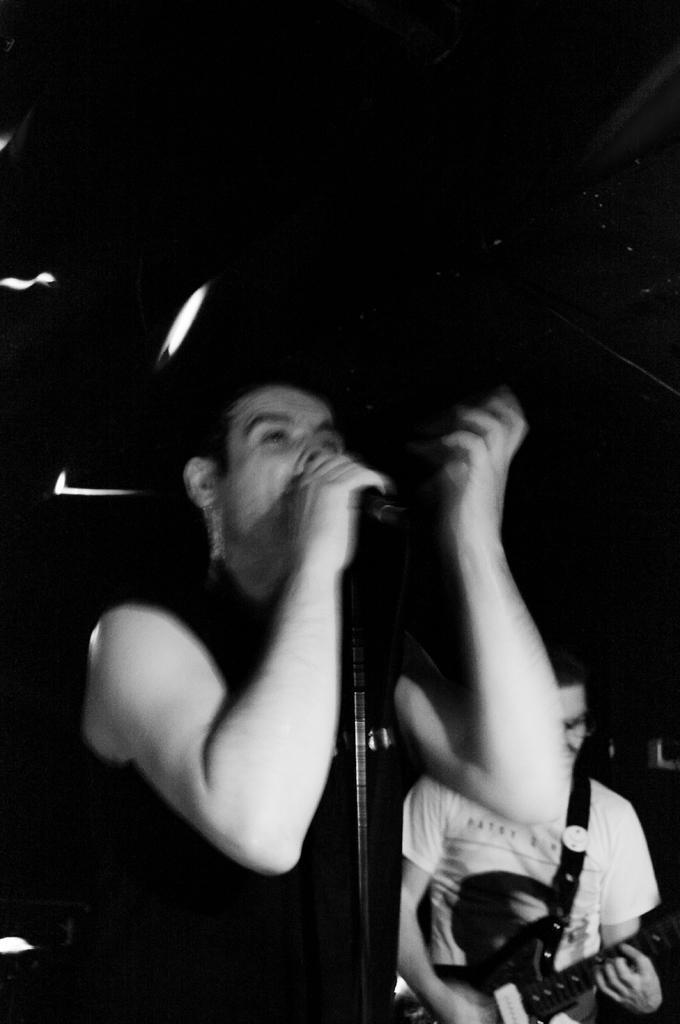Can you describe this image briefly? In this image I can see two men where one is holding a mic and another one is holding a guitar. 